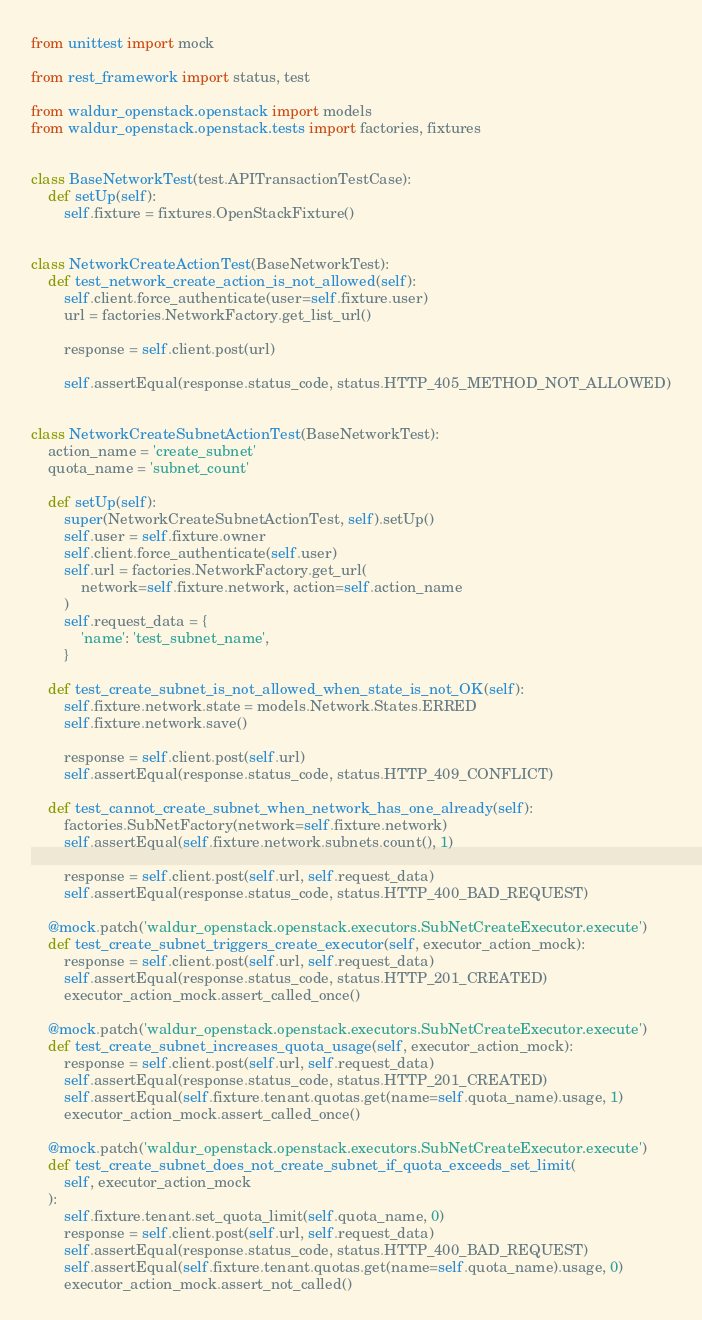<code> <loc_0><loc_0><loc_500><loc_500><_Python_>from unittest import mock

from rest_framework import status, test

from waldur_openstack.openstack import models
from waldur_openstack.openstack.tests import factories, fixtures


class BaseNetworkTest(test.APITransactionTestCase):
    def setUp(self):
        self.fixture = fixtures.OpenStackFixture()


class NetworkCreateActionTest(BaseNetworkTest):
    def test_network_create_action_is_not_allowed(self):
        self.client.force_authenticate(user=self.fixture.user)
        url = factories.NetworkFactory.get_list_url()

        response = self.client.post(url)

        self.assertEqual(response.status_code, status.HTTP_405_METHOD_NOT_ALLOWED)


class NetworkCreateSubnetActionTest(BaseNetworkTest):
    action_name = 'create_subnet'
    quota_name = 'subnet_count'

    def setUp(self):
        super(NetworkCreateSubnetActionTest, self).setUp()
        self.user = self.fixture.owner
        self.client.force_authenticate(self.user)
        self.url = factories.NetworkFactory.get_url(
            network=self.fixture.network, action=self.action_name
        )
        self.request_data = {
            'name': 'test_subnet_name',
        }

    def test_create_subnet_is_not_allowed_when_state_is_not_OK(self):
        self.fixture.network.state = models.Network.States.ERRED
        self.fixture.network.save()

        response = self.client.post(self.url)
        self.assertEqual(response.status_code, status.HTTP_409_CONFLICT)

    def test_cannot_create_subnet_when_network_has_one_already(self):
        factories.SubNetFactory(network=self.fixture.network)
        self.assertEqual(self.fixture.network.subnets.count(), 1)

        response = self.client.post(self.url, self.request_data)
        self.assertEqual(response.status_code, status.HTTP_400_BAD_REQUEST)

    @mock.patch('waldur_openstack.openstack.executors.SubNetCreateExecutor.execute')
    def test_create_subnet_triggers_create_executor(self, executor_action_mock):
        response = self.client.post(self.url, self.request_data)
        self.assertEqual(response.status_code, status.HTTP_201_CREATED)
        executor_action_mock.assert_called_once()

    @mock.patch('waldur_openstack.openstack.executors.SubNetCreateExecutor.execute')
    def test_create_subnet_increases_quota_usage(self, executor_action_mock):
        response = self.client.post(self.url, self.request_data)
        self.assertEqual(response.status_code, status.HTTP_201_CREATED)
        self.assertEqual(self.fixture.tenant.quotas.get(name=self.quota_name).usage, 1)
        executor_action_mock.assert_called_once()

    @mock.patch('waldur_openstack.openstack.executors.SubNetCreateExecutor.execute')
    def test_create_subnet_does_not_create_subnet_if_quota_exceeds_set_limit(
        self, executor_action_mock
    ):
        self.fixture.tenant.set_quota_limit(self.quota_name, 0)
        response = self.client.post(self.url, self.request_data)
        self.assertEqual(response.status_code, status.HTTP_400_BAD_REQUEST)
        self.assertEqual(self.fixture.tenant.quotas.get(name=self.quota_name).usage, 0)
        executor_action_mock.assert_not_called()

</code> 